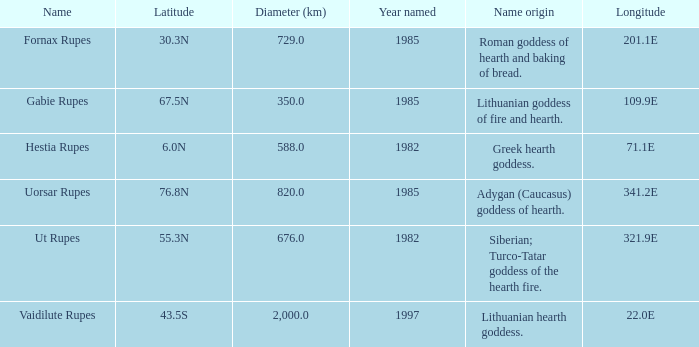What was the diameter of the feature found in 1997? 2000.0. 